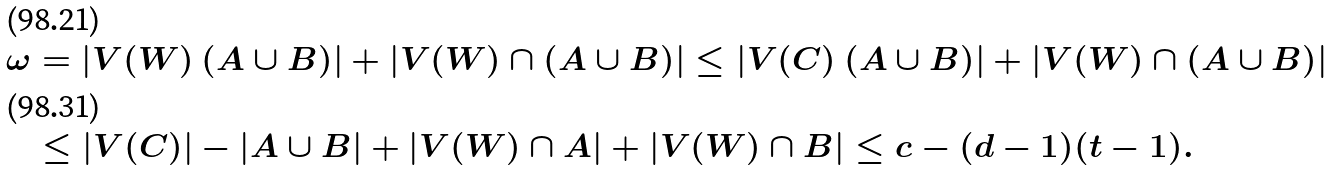<formula> <loc_0><loc_0><loc_500><loc_500>\omega & = | V ( W ) \ ( A \cup B ) | + | V ( W ) \cap ( A \cup B ) | \leq | V ( C ) \ ( A \cup B ) | + | V ( W ) \cap ( A \cup B ) | \\ & \leq | V ( C ) | - | A \cup B | + | V ( W ) \cap A | + | V ( W ) \cap B | \leq c - ( d - 1 ) ( t - 1 ) .</formula> 